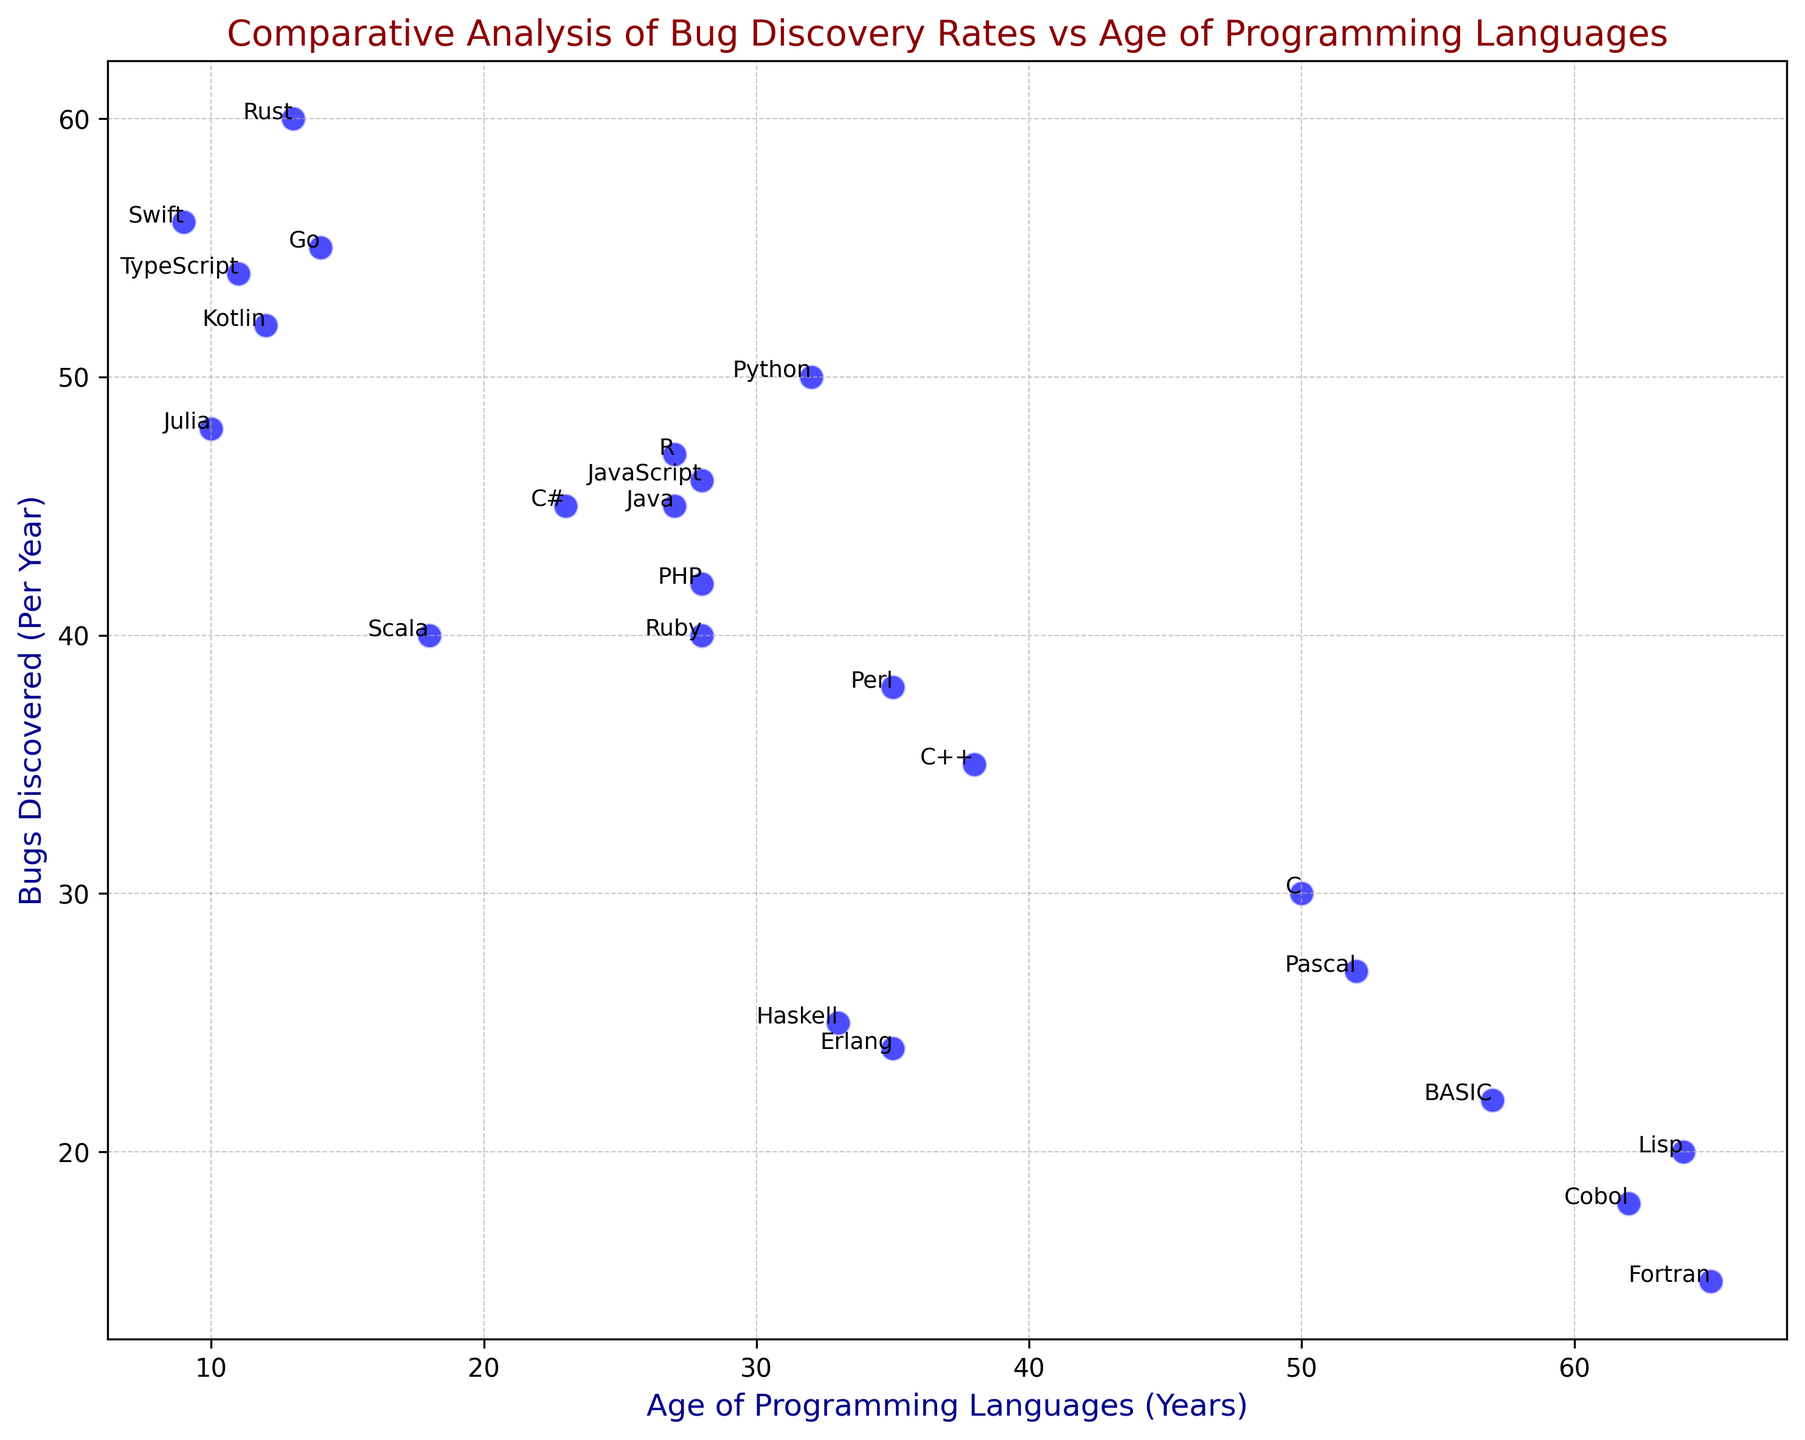Is there a clear trend between the age of a programming language and its bug discovery rate? Looking at the scatter plot, most newer languages have higher bug discovery rates, while older languages typically have lower rates.
Answer: Yes, newer languages tend to have higher bug discovery rates Which programming language has the highest bug discovery rate? By observing the y-axis, the highest point corresponds to Rust, with a bug discovery rate of 60 bugs per year.
Answer: Rust What is the age difference between the language with the highest bug discovery rate and the language with the lowest bug discovery rate? Rust (highest with an age of 13 years) and Fortran (lowest with an age of 65 years) result in a difference of 65 - 13 = 52 years.
Answer: 52 years Which languages have nearly the same bug discovery rate? Java, C#, and R, each have bug discovery rates around 45 bugs per year.
Answer: Java, C#, and R How do the bug discovery rates of older languages (over 50 years) compare to those of newer languages (under 20 years)? Older languages like Fortran, Lisp, and Cobol have lower rates (15-22), while newer ones like Go, Rust, Swift, and Kotlin have higher rates (52-60).
Answer: Older languages have lower rates; newer languages have higher rates What is the average bug discovery rate for languages between 20 and 30 years old? Languages within this range are Java, JavaScript, PHP, Ruby, Scala, and R. The rates are 45, 46, 42, 40, 40, and 47. The sum is 260, and the average is 260/6 ≈ 43.33.
Answer: ≈ 43.33 Do newer languages (under 20 years) have a higher standard deviation in bug discovery rates compared to older languages? Calculating the standard deviation: for newer languages, the rates are 55, 60, 52, 56, 54, and 48. The standard deviation is higher compared to the relatively lower and more consistent rates of older languages.
Answer: Yes What is the combined bug discovery rate of the languages older than 60 years? Fortran (15), Lisp (20), and Cobol (18). The sum is 15 + 20 + 18 = 53.
Answer: 53 Between Python and Ruby, which language has the higher bug discovery rate, and by how much? Python has 50, and Ruby has 40. The difference is 50 - 40 = 10.
Answer: Python by 10 Which language stands out as an outlier, either in age or bug discovery rates? Go is notable as an outlier because, despite being relatively new (14 years), it has a high bug discovery rate (55).
Answer: Go 